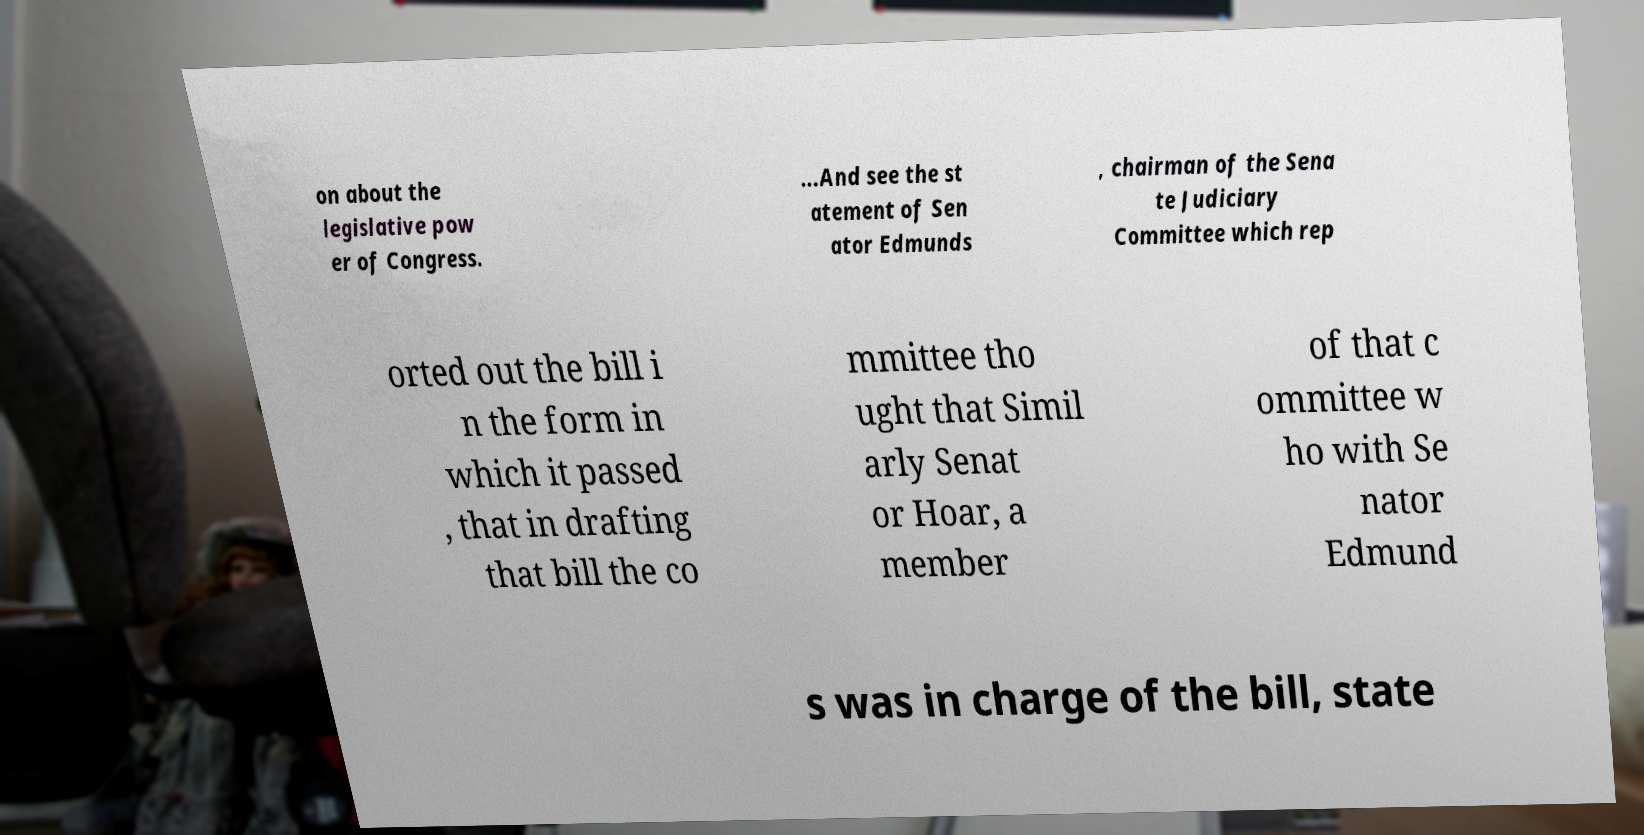Please identify and transcribe the text found in this image. on about the legislative pow er of Congress. ...And see the st atement of Sen ator Edmunds , chairman of the Sena te Judiciary Committee which rep orted out the bill i n the form in which it passed , that in drafting that bill the co mmittee tho ught that Simil arly Senat or Hoar, a member of that c ommittee w ho with Se nator Edmund s was in charge of the bill, state 